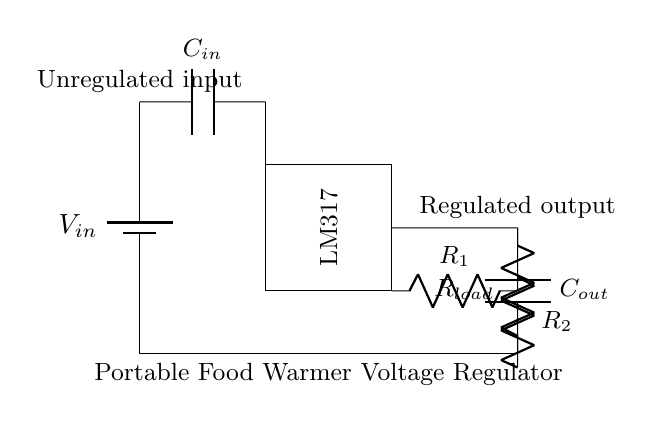What is the input component in this circuit? The input component is indicated as a battery, which provides the unregulated voltage to the circuit.
Answer: battery What is the function of the LM317 in this circuit? The LM317 serves as a voltage regulator that ensures a consistent output voltage is supplied to the load from the input voltage.
Answer: voltage regulator What type of load is represented in this circuit? The load is represented by a resistor, which signifies the heating element or device being powered by the regulated output voltage of the food warmer.
Answer: resistor How many capacitors are present in this circuit? There are two capacitors in this circuit, one at the input and one at the output, indicating filtering functions to stabilize the voltage.
Answer: two What is the purpose of the adjustment resistors R1 and R2? R1 and R2 are used in conjunction to set the desired output voltage level by adjusting the voltage divider configuration within the LM317.
Answer: adjust output voltage What voltage regulation feature does this circuit provide? This circuit provides stable voltage regulation which is critical for maintaining consistent heating temperatures in the food warmer during culinary tours.
Answer: stable voltage regulation What does the output capacitor Cout do in this circuit? The output capacitor Cout helps to smooth out the output voltage by reducing ripple and ensuring a steady supply to the load.
Answer: smooth output voltage 